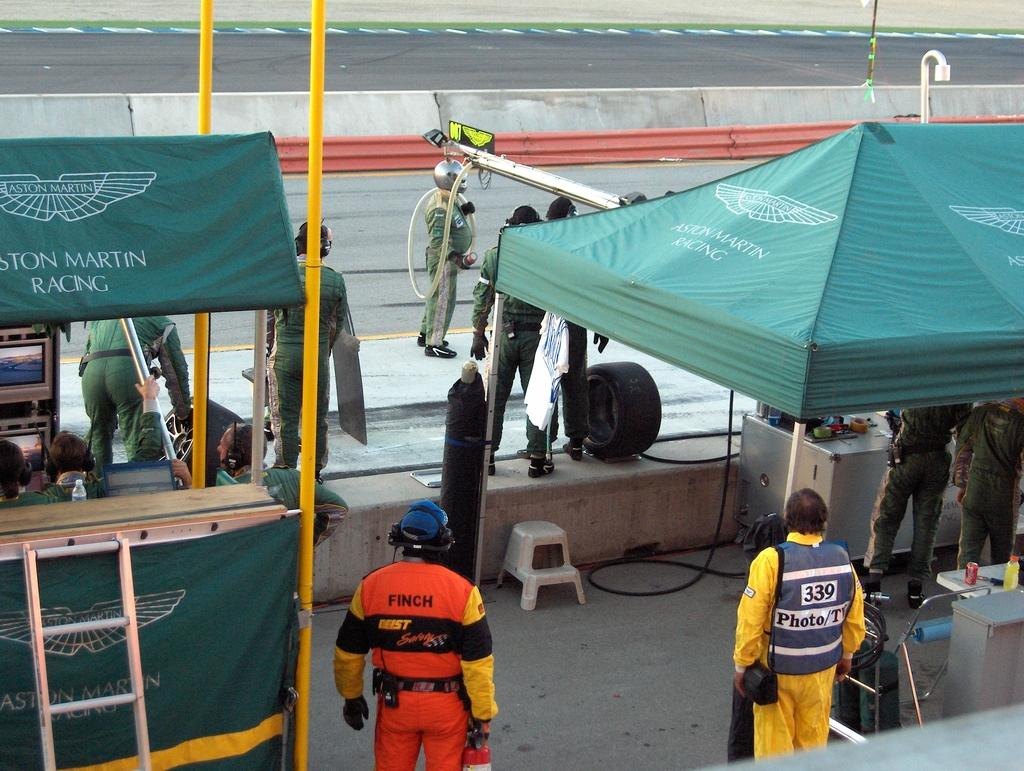What are the people in the image doing? The people in the image are standing on the road and beneath two canopies. Can you describe the objects present in the image? Unfortunately, the provided facts do not specify any objects present in the image. What page of the book does the quarter suggest in the image? There is no book or quarter present in the image, so this question cannot be answered. 